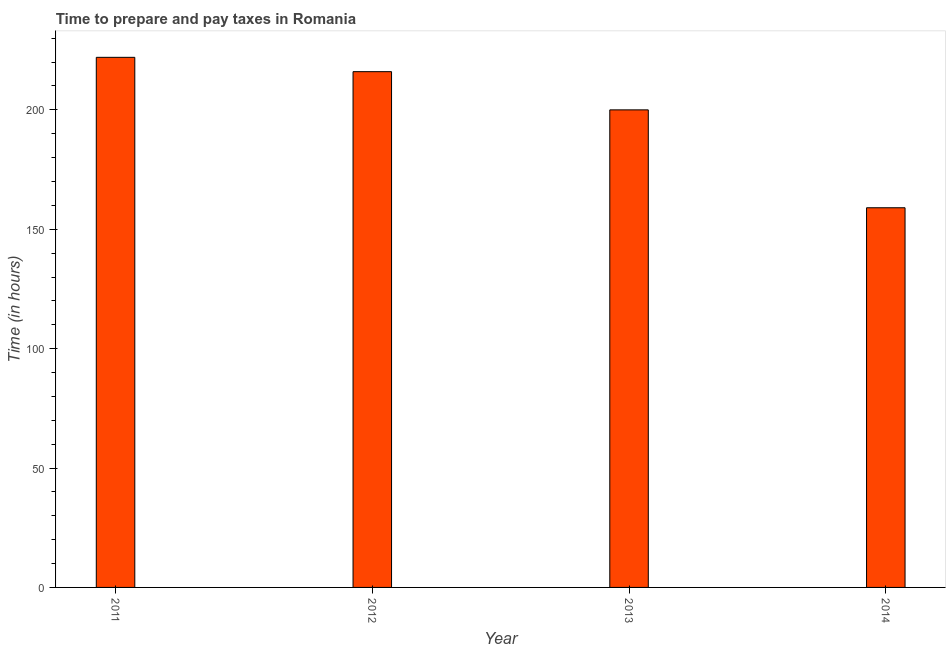What is the title of the graph?
Provide a succinct answer. Time to prepare and pay taxes in Romania. What is the label or title of the Y-axis?
Give a very brief answer. Time (in hours). What is the time to prepare and pay taxes in 2014?
Offer a very short reply. 159. Across all years, what is the maximum time to prepare and pay taxes?
Give a very brief answer. 222. Across all years, what is the minimum time to prepare and pay taxes?
Give a very brief answer. 159. In which year was the time to prepare and pay taxes maximum?
Your response must be concise. 2011. In which year was the time to prepare and pay taxes minimum?
Your answer should be compact. 2014. What is the sum of the time to prepare and pay taxes?
Give a very brief answer. 797. What is the average time to prepare and pay taxes per year?
Give a very brief answer. 199. What is the median time to prepare and pay taxes?
Your answer should be very brief. 208. Do a majority of the years between 2014 and 2012 (inclusive) have time to prepare and pay taxes greater than 40 hours?
Provide a short and direct response. Yes. Is the time to prepare and pay taxes in 2013 less than that in 2014?
Provide a short and direct response. No. Is the difference between the time to prepare and pay taxes in 2012 and 2014 greater than the difference between any two years?
Give a very brief answer. No. How many bars are there?
Your answer should be compact. 4. Are all the bars in the graph horizontal?
Ensure brevity in your answer.  No. What is the Time (in hours) in 2011?
Ensure brevity in your answer.  222. What is the Time (in hours) of 2012?
Provide a short and direct response. 216. What is the Time (in hours) in 2013?
Make the answer very short. 200. What is the Time (in hours) in 2014?
Provide a succinct answer. 159. What is the difference between the Time (in hours) in 2011 and 2012?
Provide a succinct answer. 6. What is the difference between the Time (in hours) in 2011 and 2013?
Provide a short and direct response. 22. What is the difference between the Time (in hours) in 2012 and 2014?
Keep it short and to the point. 57. What is the difference between the Time (in hours) in 2013 and 2014?
Your answer should be compact. 41. What is the ratio of the Time (in hours) in 2011 to that in 2012?
Ensure brevity in your answer.  1.03. What is the ratio of the Time (in hours) in 2011 to that in 2013?
Provide a succinct answer. 1.11. What is the ratio of the Time (in hours) in 2011 to that in 2014?
Your answer should be very brief. 1.4. What is the ratio of the Time (in hours) in 2012 to that in 2013?
Provide a short and direct response. 1.08. What is the ratio of the Time (in hours) in 2012 to that in 2014?
Offer a terse response. 1.36. What is the ratio of the Time (in hours) in 2013 to that in 2014?
Your answer should be compact. 1.26. 